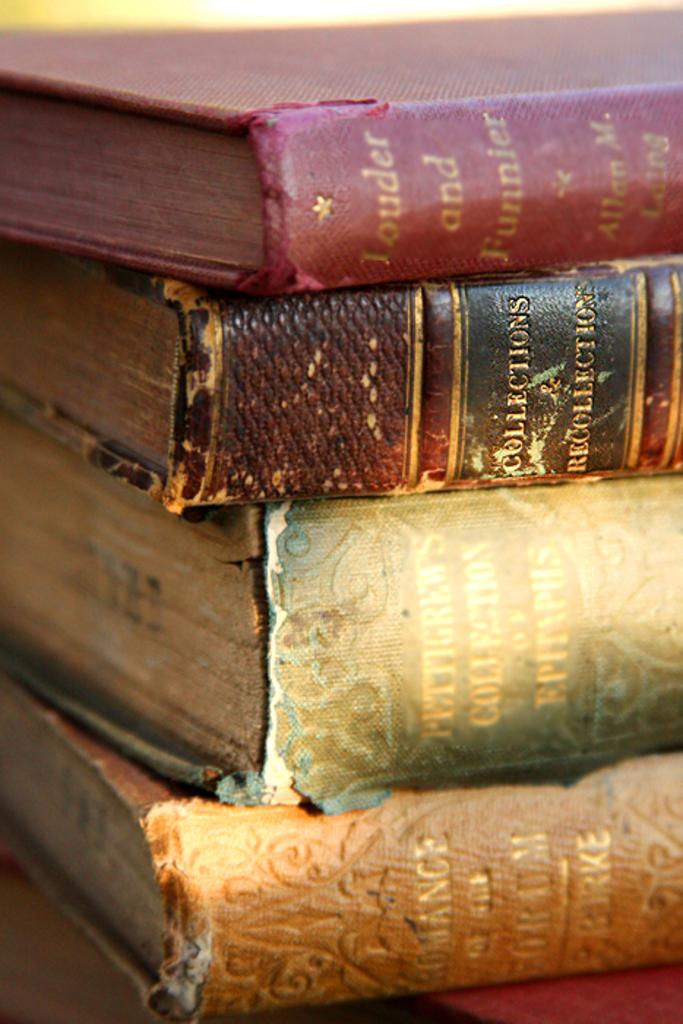What is the title of the red book?
Make the answer very short. Louder and funnier. What is the title of the dark brown book?
Your answer should be very brief. Collections & recollections. 